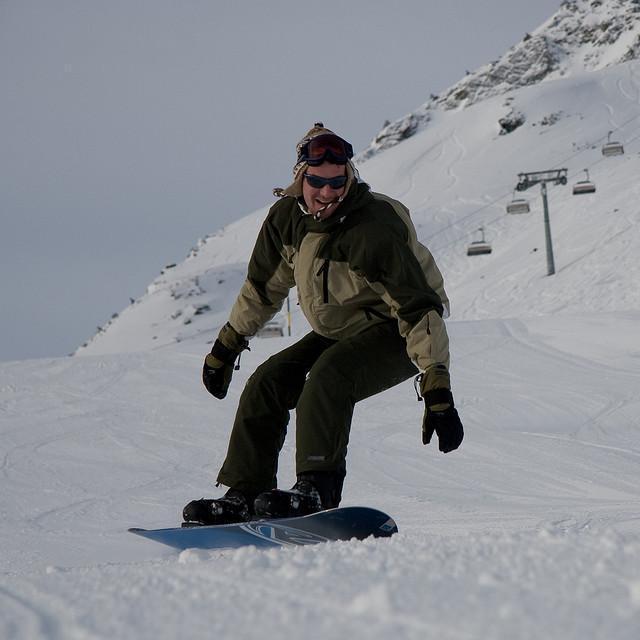How many ski lifts can you see?
Give a very brief answer. 4. 